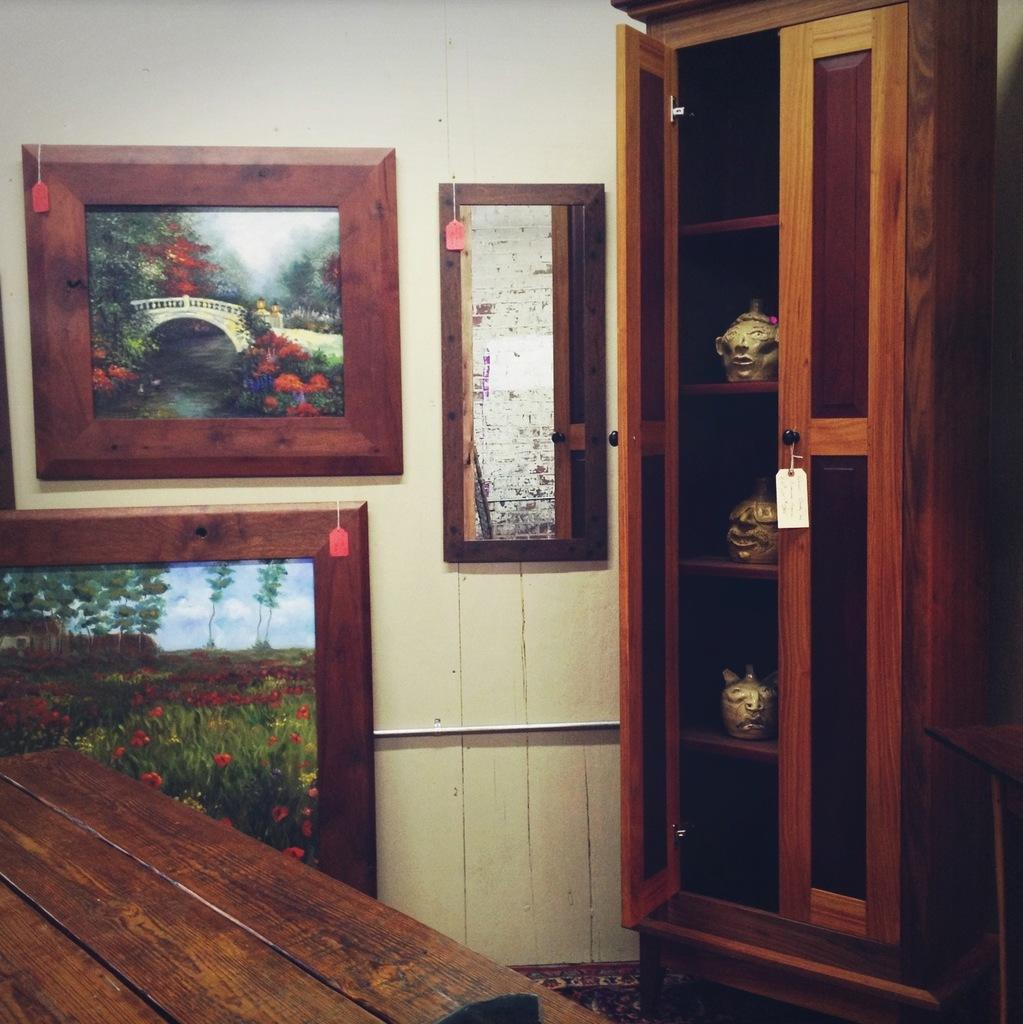What type of furniture is present in the image? There is a wooden table in the image. What can be seen on the wall in the background? There are frames attached to the wall in the background. What color is the wall in the image? The wall is in cream color. What other piece of furniture can be seen in the image? There is a cupboard in brown color in the image. How is the garden divided in the image? There is no garden present in the image, so it cannot be divided. 